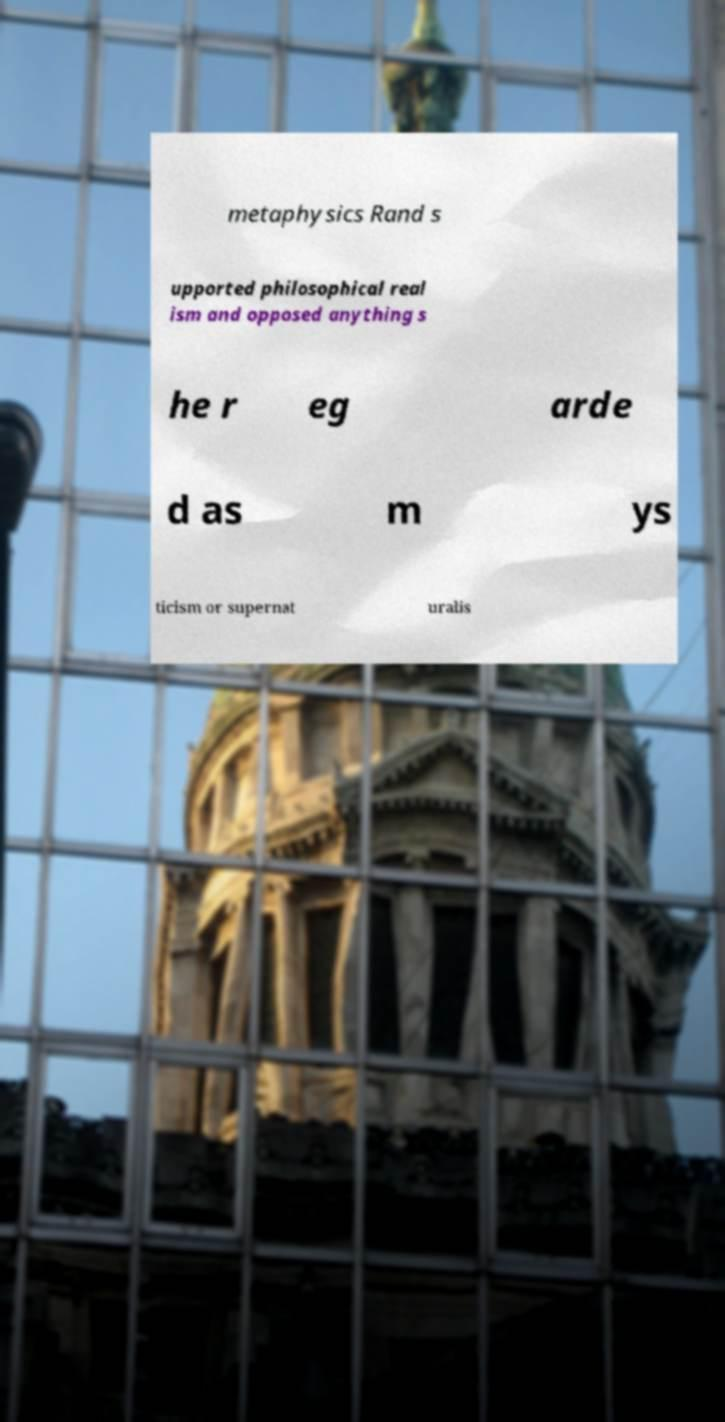Please identify and transcribe the text found in this image. metaphysics Rand s upported philosophical real ism and opposed anything s he r eg arde d as m ys ticism or supernat uralis 